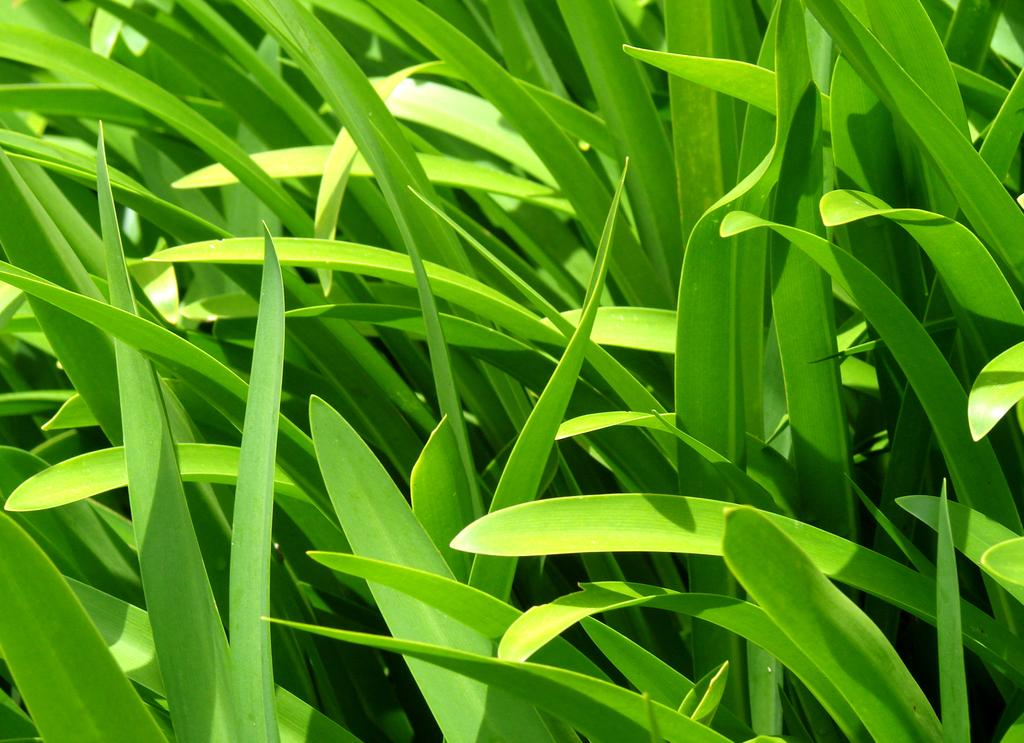What type of plant is depicted in the image? The image contains broad green leaves of a plant. Can you describe the color and texture of the leaves? The leaves are green and appear to be broad. What might be the purpose of this plant or its leaves? It is difficult to determine the purpose of the plant or its leaves from the image alone. What type of tax does the bear pay on the man's property in the image? There is no bear or man present in the image, and therefore no tax situation can be observed. 